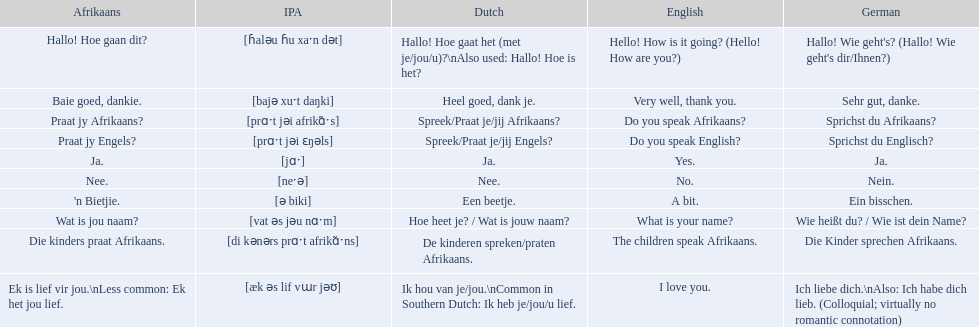How do you say do you speak english in german? Sprichst du Englisch?. What about do you speak afrikaanss? in afrikaans? Praat jy Afrikaans?. 